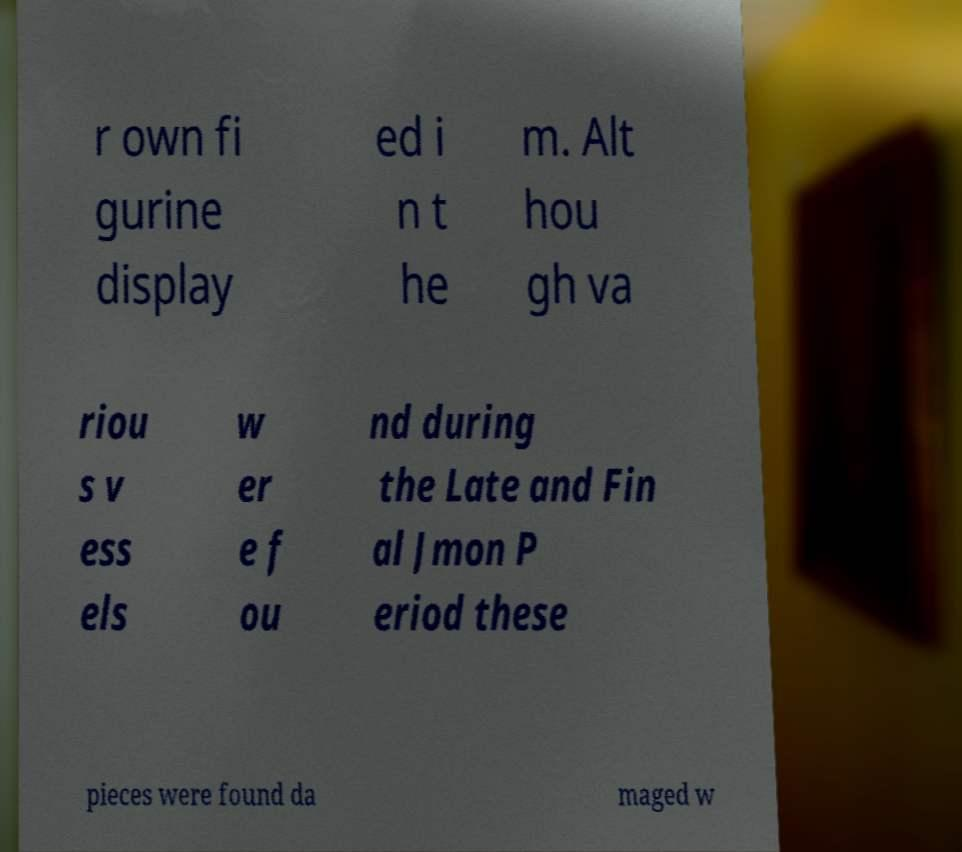Please read and relay the text visible in this image. What does it say? r own fi gurine display ed i n t he m. Alt hou gh va riou s v ess els w er e f ou nd during the Late and Fin al Jmon P eriod these pieces were found da maged w 